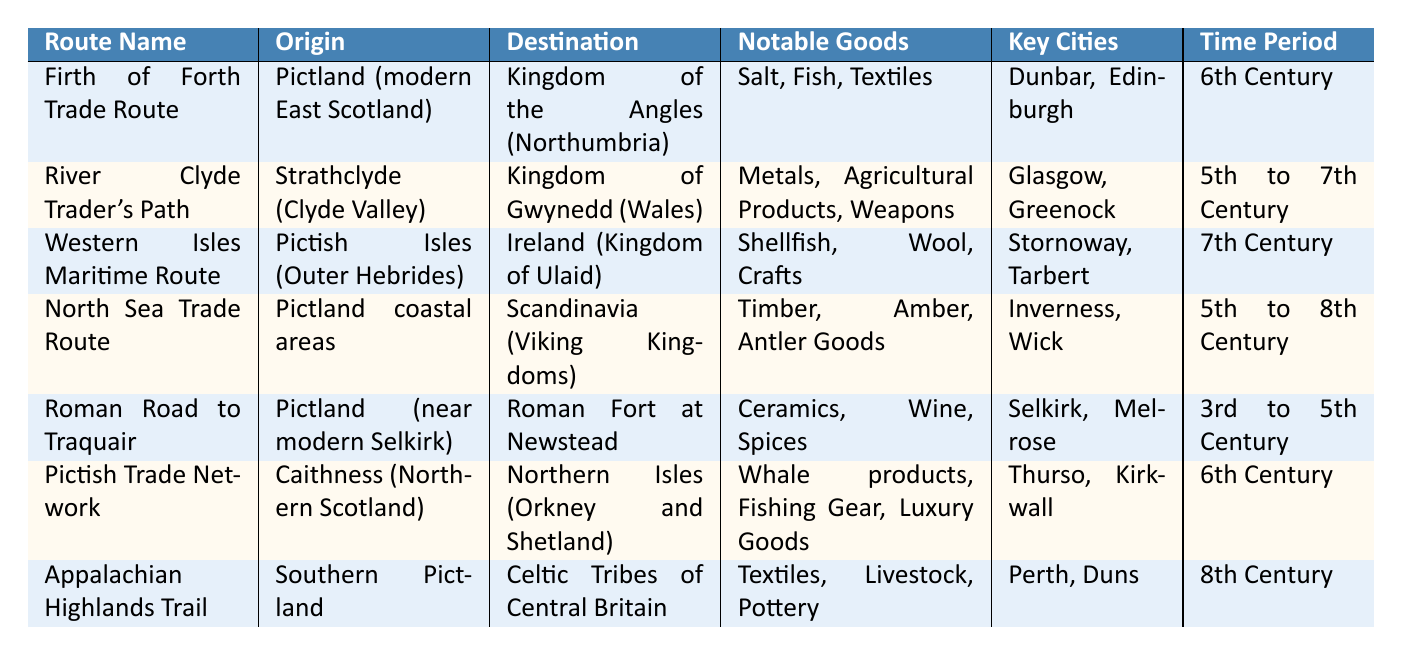What is the key city located at the origin of the Firth of Forth Trade Route? The Firth of Forth Trade Route originates from Pictland, where one of the key cities listed is Dunbar.
Answer: Dunbar Which route connects Pictland to the Kingdom of Ulaid? The Western Isles Maritime Route connects Pictland's Isles to the Kingdom of Ulaid in Ireland.
Answer: Western Isles Maritime Route What notable goods were traded through the North Sea Trade Route? The North Sea Trade Route had Timber, Amber, and Antler Goods listed as notable goods.
Answer: Timber, Amber, Antler Goods Which kingdom was the destination of the River Clyde Trader's Path? The River Clyde Trader's Path leads to the Kingdom of Gwynedd in Wales.
Answer: Kingdom of Gwynedd During which century was the Roman Road to Traquair most active? The Roman Road to Traquair was most active during the 3rd to 5th Century.
Answer: 3rd to 5th Century Was the Pictish Trade Network involved in trading Whale products? Yes, the Pictish Trade Network is listed as trading Whale products among other goods.
Answer: Yes What is the average time period of trade routes that focus on agricultural products? The River Clyde Trader's Path (5th to 7th Century) and the Appalachian Highlands Trail (8th Century) are focused on agricultural products; their average time period is (5.5 + 8) / 2 = 6.25, which can be considered the 6th Century.
Answer: 6th Century Which trade route had the broadest time frame for activity? The North Sea Trade Route spans from the 5th to the 8th Century, making it the broadest time frame.
Answer: North Sea Trade Route How many key cities are listed for the Western Isles Maritime Route? The Western Isles Maritime Route has two key cities listed: Stornoway and Tarbert.
Answer: 2 What types of goods were exchanged through the Appalachian Highlands Trail? The Appalachian Highlands Trail exchanged Textiles, Livestock, and Pottery.
Answer: Textiles, Livestock, Pottery Which trade route was primarily active during the 6th Century? Both the Firth of Forth Trade Route and the Pictish Trade Network were primarily active during the 6th Century.
Answer: Two routes 